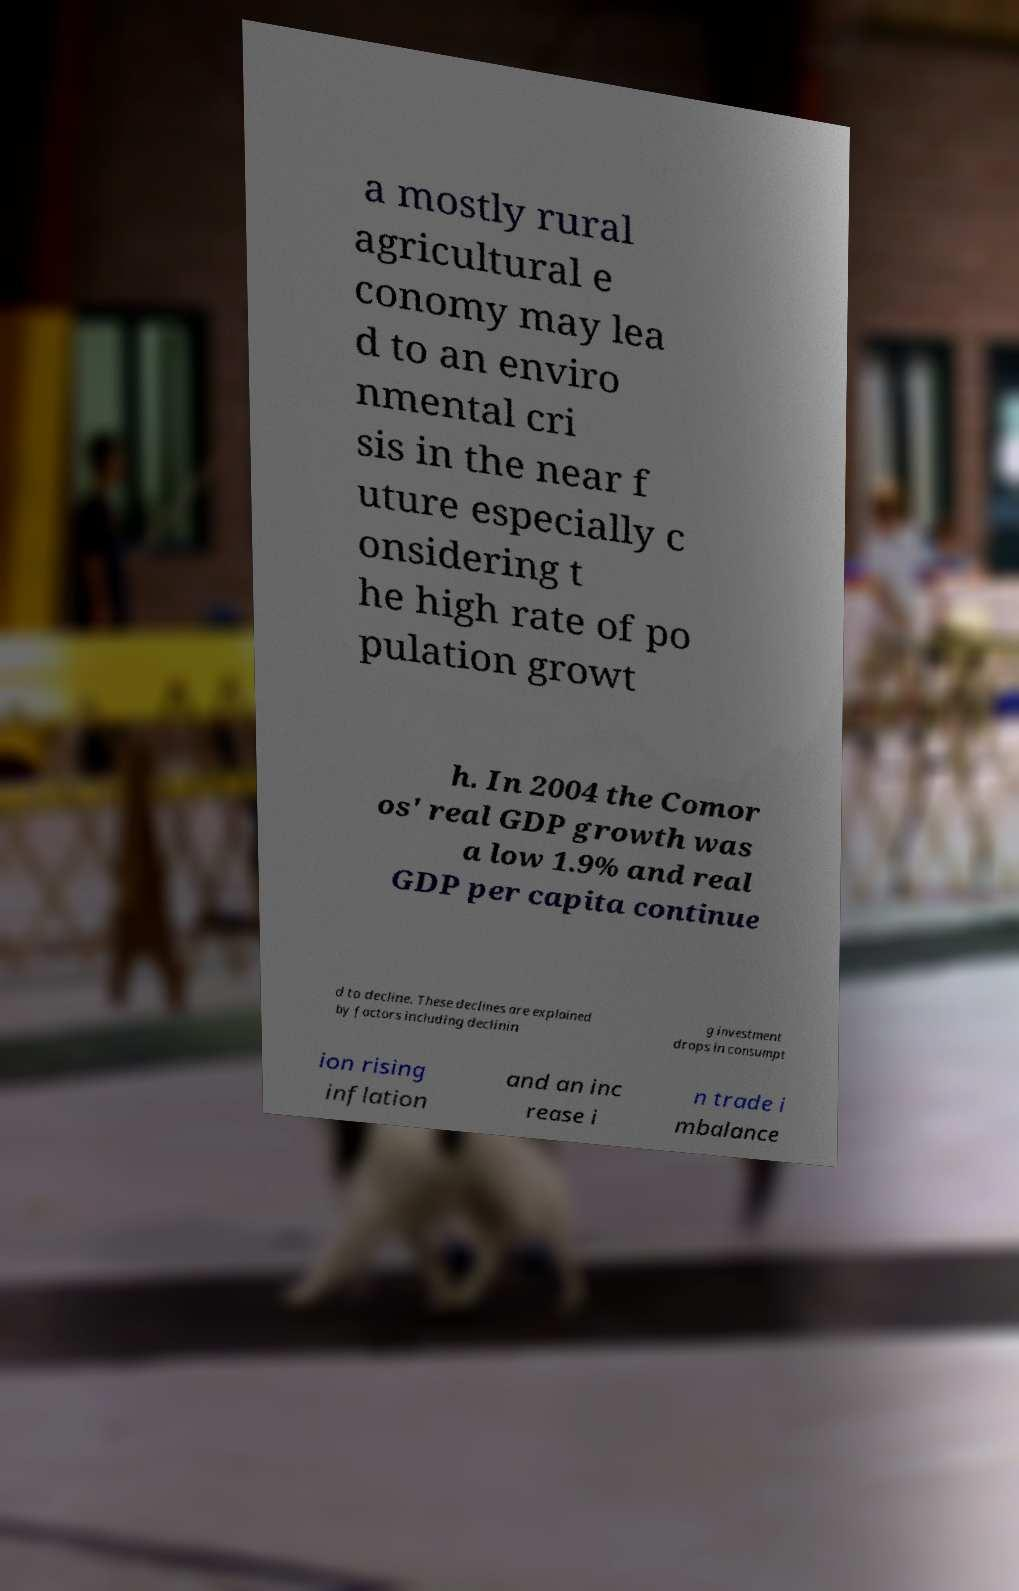Could you assist in decoding the text presented in this image and type it out clearly? a mostly rural agricultural e conomy may lea d to an enviro nmental cri sis in the near f uture especially c onsidering t he high rate of po pulation growt h. In 2004 the Comor os' real GDP growth was a low 1.9% and real GDP per capita continue d to decline. These declines are explained by factors including declinin g investment drops in consumpt ion rising inflation and an inc rease i n trade i mbalance 